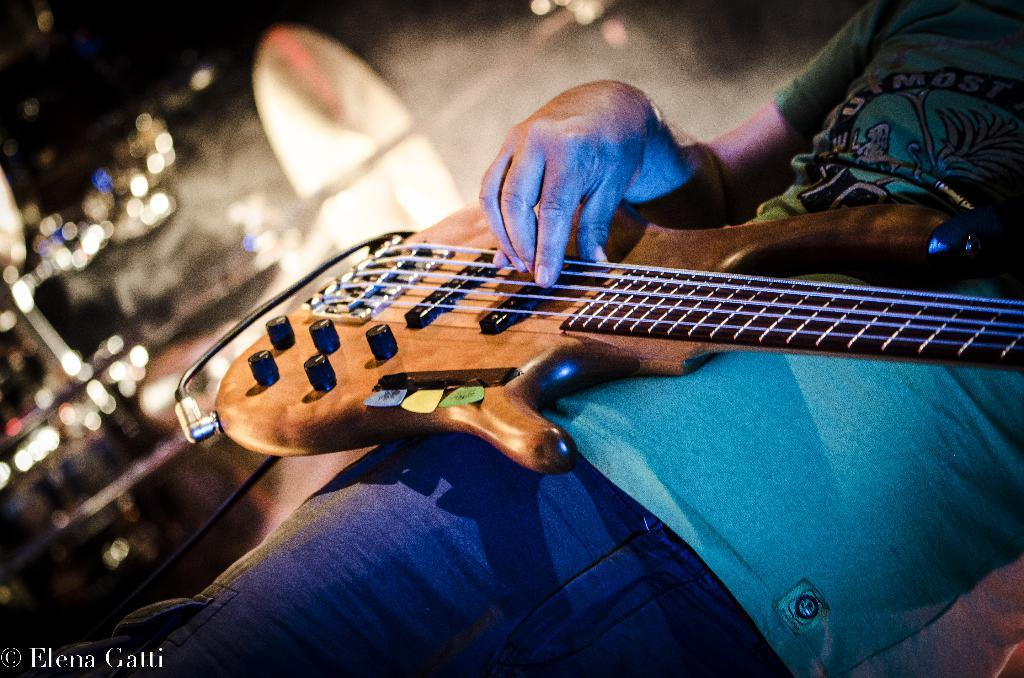What is the main subject of the image? There is a person standing in the image. What is the person wearing or holding in the image? The person is wearing a guitar. What can be seen in the background of the image? There are lights visible in the background of the image. How many rabbits are sitting on the person's grandmother's lap in the image? There are no rabbits or grandmothers present in the image. 